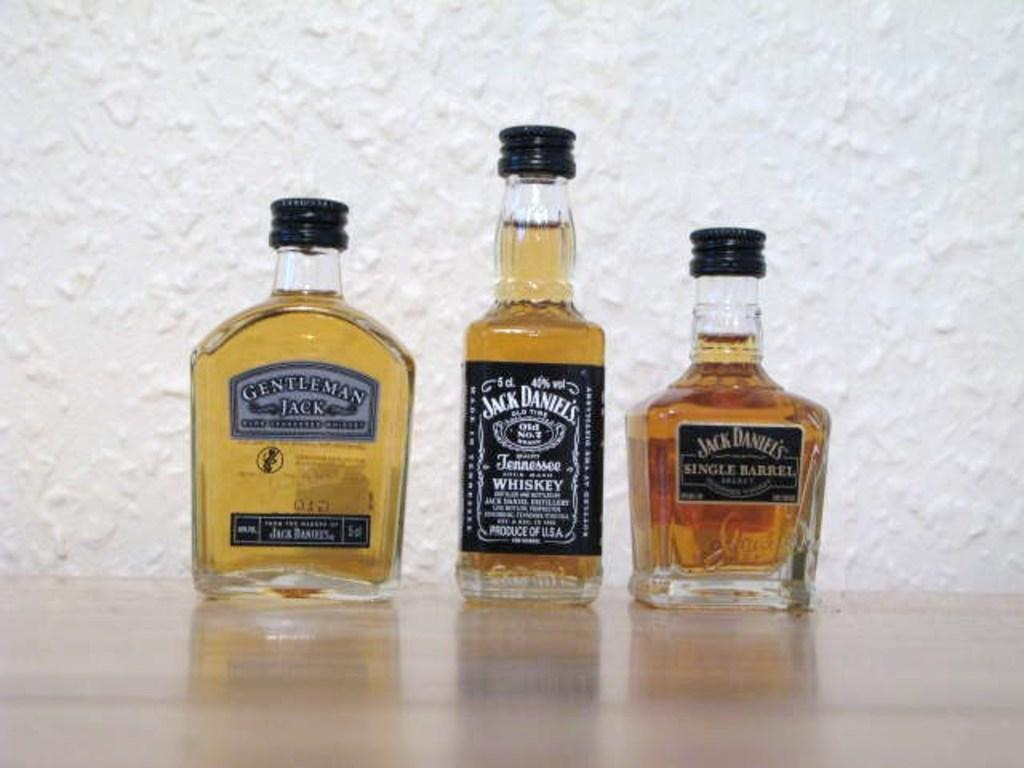Provide a one-sentence caption for the provided image. Three different bottles of Jack Daniel's are lined up side by side. 